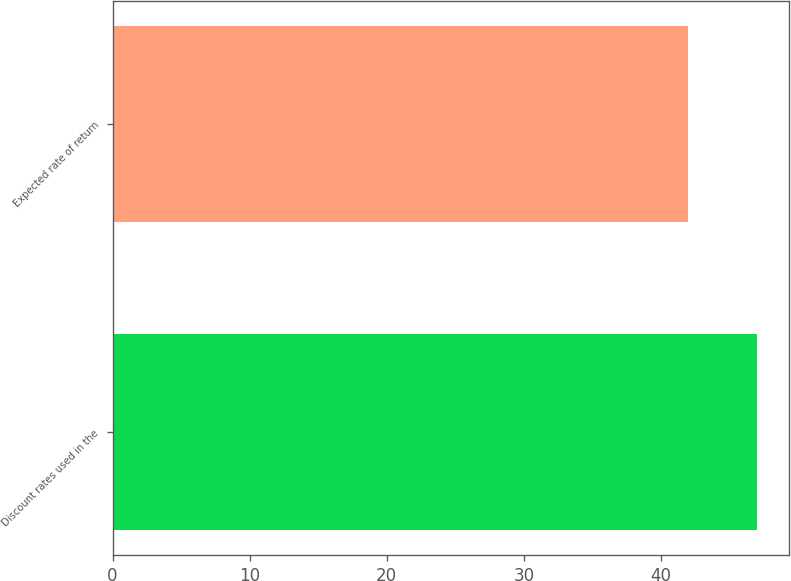<chart> <loc_0><loc_0><loc_500><loc_500><bar_chart><fcel>Discount rates used in the<fcel>Expected rate of return<nl><fcel>47<fcel>42<nl></chart> 